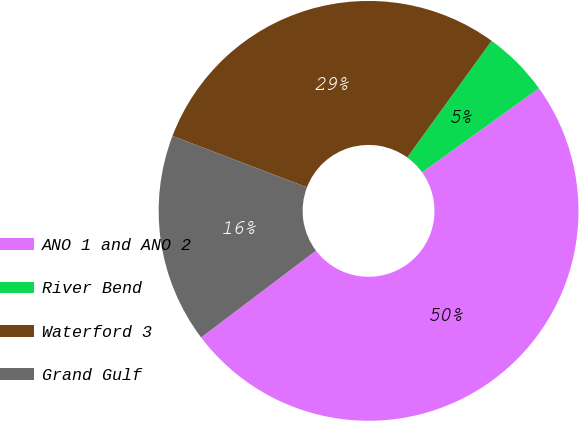<chart> <loc_0><loc_0><loc_500><loc_500><pie_chart><fcel>ANO 1 and ANO 2<fcel>River Bend<fcel>Waterford 3<fcel>Grand Gulf<nl><fcel>49.62%<fcel>5.11%<fcel>29.16%<fcel>16.11%<nl></chart> 